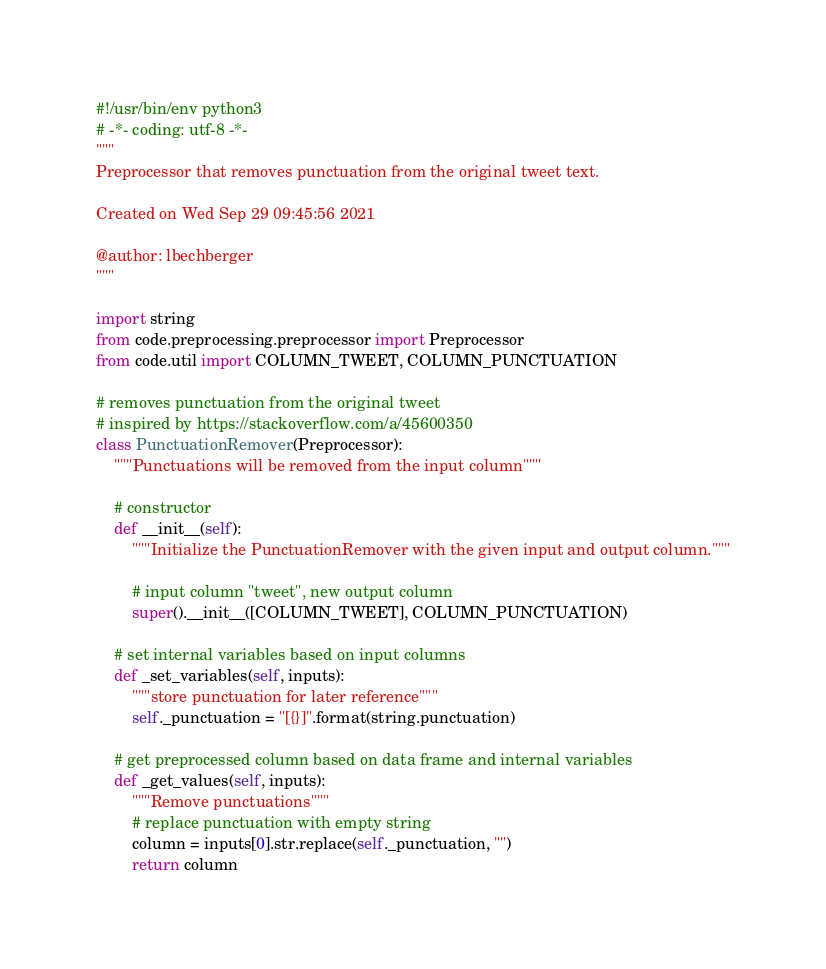Convert code to text. <code><loc_0><loc_0><loc_500><loc_500><_Python_>#!/usr/bin/env python3
# -*- coding: utf-8 -*-
"""
Preprocessor that removes punctuation from the original tweet text.

Created on Wed Sep 29 09:45:56 2021

@author: lbechberger
"""

import string
from code.preprocessing.preprocessor import Preprocessor
from code.util import COLUMN_TWEET, COLUMN_PUNCTUATION

# removes punctuation from the original tweet
# inspired by https://stackoverflow.com/a/45600350
class PunctuationRemover(Preprocessor):
    """Punctuations will be removed from the input column"""
    
    # constructor
    def __init__(self):
        """Initialize the PunctuationRemover with the given input and output column."""
        
        # input column "tweet", new output column
        super().__init__([COLUMN_TWEET], COLUMN_PUNCTUATION)
    
    # set internal variables based on input columns
    def _set_variables(self, inputs):
        """store punctuation for later reference"""
        self._punctuation = "[{}]".format(string.punctuation)
    
    # get preprocessed column based on data frame and internal variables
    def _get_values(self, inputs):
        """Remove punctuations"""
        # replace punctuation with empty string
        column = inputs[0].str.replace(self._punctuation, "")
        return column</code> 